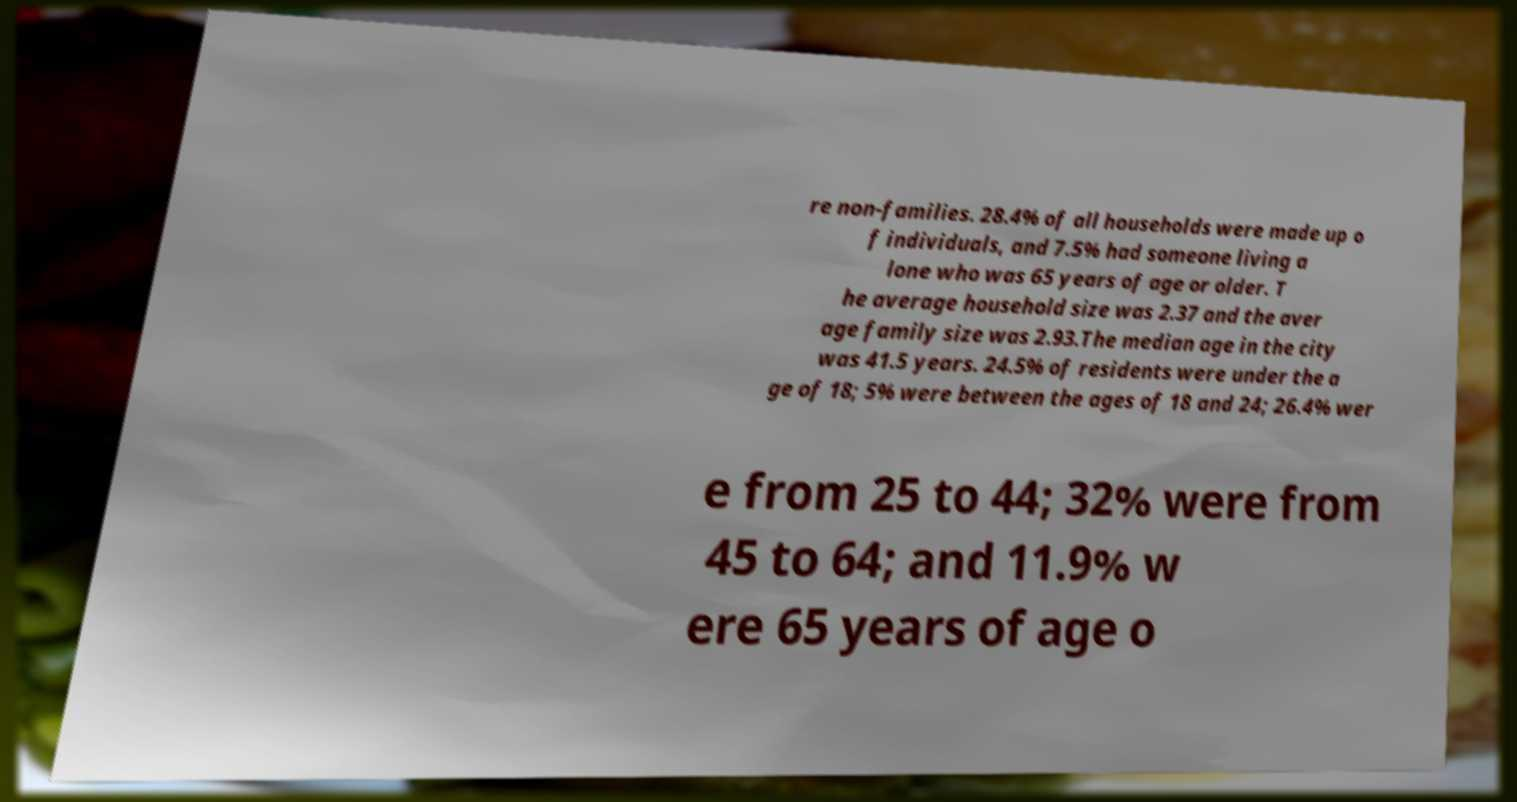Could you extract and type out the text from this image? re non-families. 28.4% of all households were made up o f individuals, and 7.5% had someone living a lone who was 65 years of age or older. T he average household size was 2.37 and the aver age family size was 2.93.The median age in the city was 41.5 years. 24.5% of residents were under the a ge of 18; 5% were between the ages of 18 and 24; 26.4% wer e from 25 to 44; 32% were from 45 to 64; and 11.9% w ere 65 years of age o 